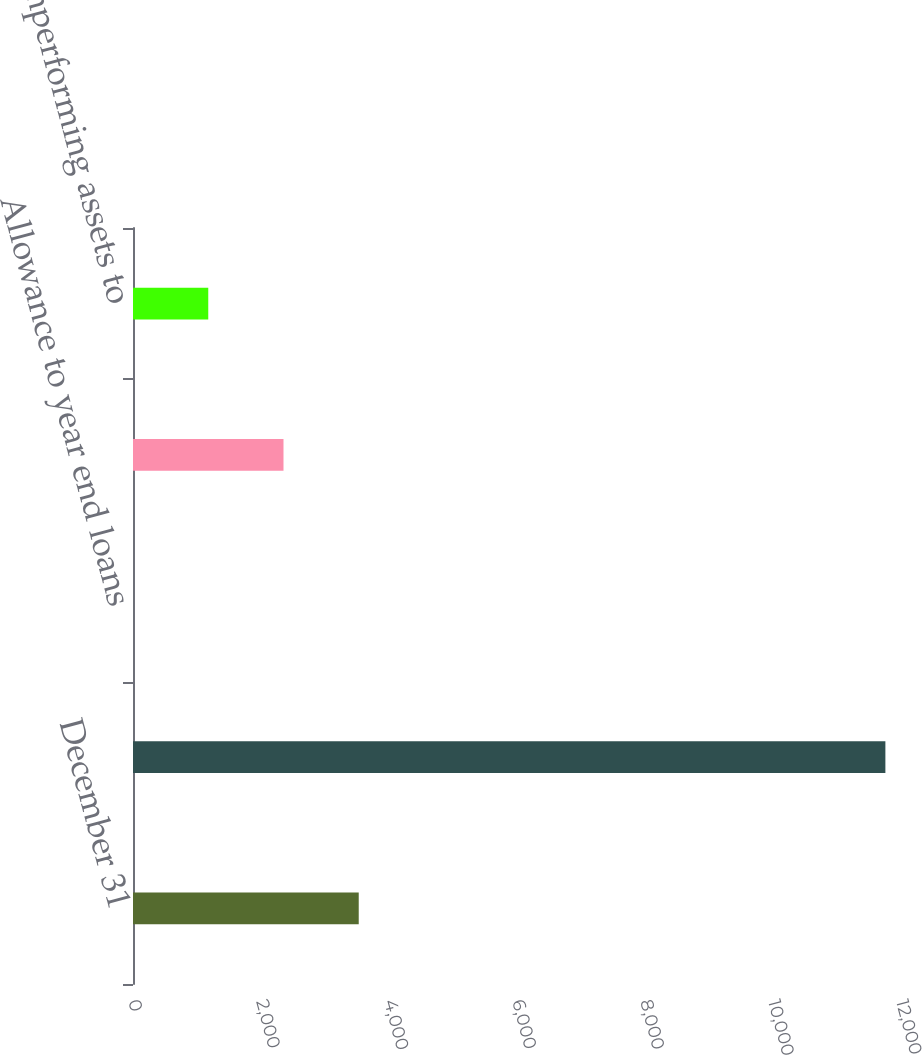<chart> <loc_0><loc_0><loc_500><loc_500><bar_chart><fcel>December 31<fcel>Average loans<fcel>Allowance to year end loans<fcel>Allowance to nonperforming<fcel>Nonperforming assets to<nl><fcel>3527.07<fcel>11756<fcel>0.39<fcel>2351.51<fcel>1175.95<nl></chart> 